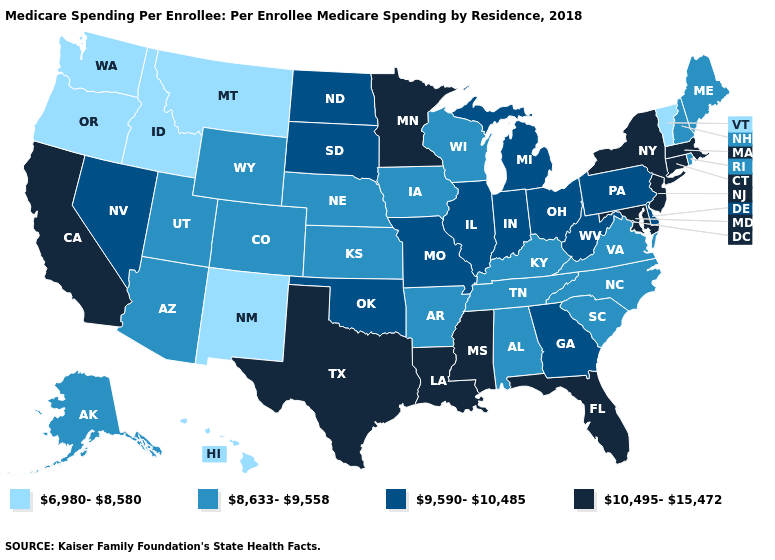What is the highest value in the USA?
Keep it brief. 10,495-15,472. What is the highest value in the USA?
Short answer required. 10,495-15,472. Name the states that have a value in the range 8,633-9,558?
Quick response, please. Alabama, Alaska, Arizona, Arkansas, Colorado, Iowa, Kansas, Kentucky, Maine, Nebraska, New Hampshire, North Carolina, Rhode Island, South Carolina, Tennessee, Utah, Virginia, Wisconsin, Wyoming. Name the states that have a value in the range 10,495-15,472?
Give a very brief answer. California, Connecticut, Florida, Louisiana, Maryland, Massachusetts, Minnesota, Mississippi, New Jersey, New York, Texas. What is the value of Louisiana?
Keep it brief. 10,495-15,472. Does Washington have the lowest value in the USA?
Write a very short answer. Yes. Among the states that border Utah , which have the lowest value?
Concise answer only. Idaho, New Mexico. Does the map have missing data?
Short answer required. No. Which states have the highest value in the USA?
Keep it brief. California, Connecticut, Florida, Louisiana, Maryland, Massachusetts, Minnesota, Mississippi, New Jersey, New York, Texas. Which states hav the highest value in the MidWest?
Give a very brief answer. Minnesota. What is the value of Missouri?
Write a very short answer. 9,590-10,485. Name the states that have a value in the range 10,495-15,472?
Quick response, please. California, Connecticut, Florida, Louisiana, Maryland, Massachusetts, Minnesota, Mississippi, New Jersey, New York, Texas. What is the value of Minnesota?
Keep it brief. 10,495-15,472. Name the states that have a value in the range 10,495-15,472?
Be succinct. California, Connecticut, Florida, Louisiana, Maryland, Massachusetts, Minnesota, Mississippi, New Jersey, New York, Texas. What is the highest value in states that border New Jersey?
Quick response, please. 10,495-15,472. 